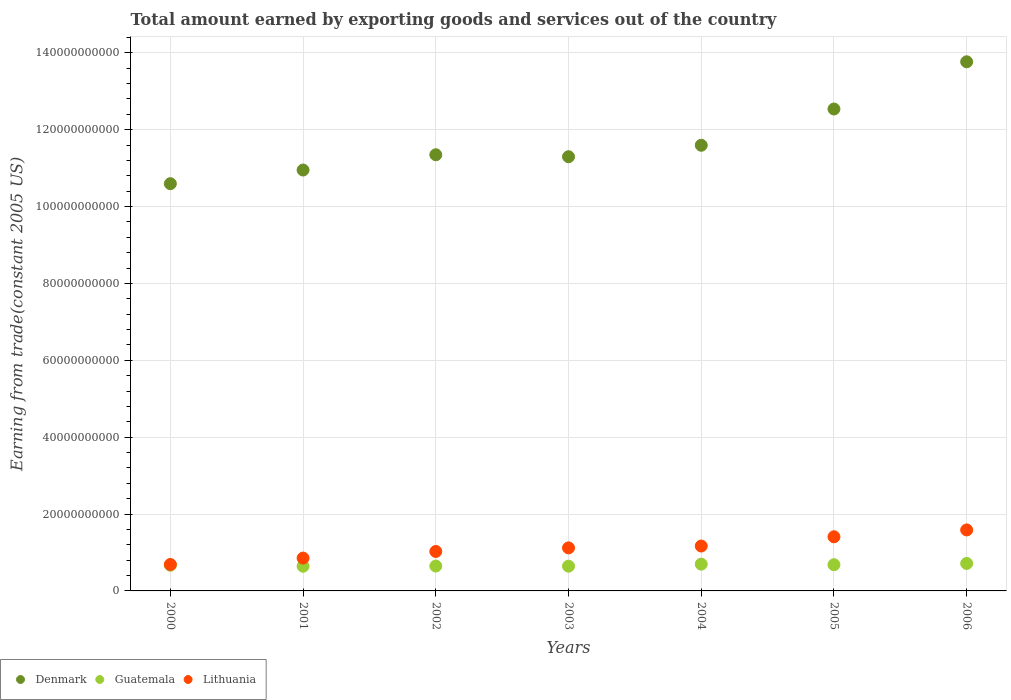How many different coloured dotlines are there?
Make the answer very short. 3. Is the number of dotlines equal to the number of legend labels?
Give a very brief answer. Yes. What is the total amount earned by exporting goods and services in Guatemala in 2000?
Provide a succinct answer. 6.69e+09. Across all years, what is the maximum total amount earned by exporting goods and services in Lithuania?
Give a very brief answer. 1.59e+1. Across all years, what is the minimum total amount earned by exporting goods and services in Denmark?
Offer a very short reply. 1.06e+11. In which year was the total amount earned by exporting goods and services in Denmark maximum?
Provide a short and direct response. 2006. In which year was the total amount earned by exporting goods and services in Lithuania minimum?
Make the answer very short. 2000. What is the total total amount earned by exporting goods and services in Lithuania in the graph?
Give a very brief answer. 7.85e+1. What is the difference between the total amount earned by exporting goods and services in Guatemala in 2002 and that in 2005?
Your answer should be very brief. -3.48e+08. What is the difference between the total amount earned by exporting goods and services in Lithuania in 2004 and the total amount earned by exporting goods and services in Guatemala in 2003?
Make the answer very short. 5.24e+09. What is the average total amount earned by exporting goods and services in Lithuania per year?
Your response must be concise. 1.12e+1. In the year 2006, what is the difference between the total amount earned by exporting goods and services in Lithuania and total amount earned by exporting goods and services in Guatemala?
Your answer should be very brief. 8.72e+09. In how many years, is the total amount earned by exporting goods and services in Denmark greater than 48000000000 US$?
Your response must be concise. 7. What is the ratio of the total amount earned by exporting goods and services in Lithuania in 2001 to that in 2002?
Make the answer very short. 0.83. Is the difference between the total amount earned by exporting goods and services in Lithuania in 2002 and 2003 greater than the difference between the total amount earned by exporting goods and services in Guatemala in 2002 and 2003?
Offer a very short reply. No. What is the difference between the highest and the second highest total amount earned by exporting goods and services in Guatemala?
Make the answer very short. 1.80e+08. What is the difference between the highest and the lowest total amount earned by exporting goods and services in Guatemala?
Give a very brief answer. 7.21e+08. Is it the case that in every year, the sum of the total amount earned by exporting goods and services in Denmark and total amount earned by exporting goods and services in Lithuania  is greater than the total amount earned by exporting goods and services in Guatemala?
Offer a very short reply. Yes. Does the total amount earned by exporting goods and services in Denmark monotonically increase over the years?
Keep it short and to the point. No. Is the total amount earned by exporting goods and services in Guatemala strictly less than the total amount earned by exporting goods and services in Lithuania over the years?
Offer a very short reply. Yes. How many years are there in the graph?
Make the answer very short. 7. What is the difference between two consecutive major ticks on the Y-axis?
Offer a very short reply. 2.00e+1. Are the values on the major ticks of Y-axis written in scientific E-notation?
Make the answer very short. No. What is the title of the graph?
Provide a succinct answer. Total amount earned by exporting goods and services out of the country. Does "Gabon" appear as one of the legend labels in the graph?
Your answer should be compact. No. What is the label or title of the Y-axis?
Provide a succinct answer. Earning from trade(constant 2005 US). What is the Earning from trade(constant 2005 US) in Denmark in 2000?
Your answer should be compact. 1.06e+11. What is the Earning from trade(constant 2005 US) in Guatemala in 2000?
Your answer should be compact. 6.69e+09. What is the Earning from trade(constant 2005 US) in Lithuania in 2000?
Keep it short and to the point. 6.88e+09. What is the Earning from trade(constant 2005 US) of Denmark in 2001?
Provide a succinct answer. 1.10e+11. What is the Earning from trade(constant 2005 US) of Guatemala in 2001?
Offer a very short reply. 6.42e+09. What is the Earning from trade(constant 2005 US) in Lithuania in 2001?
Make the answer very short. 8.54e+09. What is the Earning from trade(constant 2005 US) of Denmark in 2002?
Provide a succinct answer. 1.13e+11. What is the Earning from trade(constant 2005 US) in Guatemala in 2002?
Keep it short and to the point. 6.47e+09. What is the Earning from trade(constant 2005 US) of Lithuania in 2002?
Offer a terse response. 1.03e+1. What is the Earning from trade(constant 2005 US) in Denmark in 2003?
Provide a succinct answer. 1.13e+11. What is the Earning from trade(constant 2005 US) of Guatemala in 2003?
Offer a very short reply. 6.44e+09. What is the Earning from trade(constant 2005 US) in Lithuania in 2003?
Ensure brevity in your answer.  1.12e+1. What is the Earning from trade(constant 2005 US) in Denmark in 2004?
Provide a succinct answer. 1.16e+11. What is the Earning from trade(constant 2005 US) of Guatemala in 2004?
Make the answer very short. 6.96e+09. What is the Earning from trade(constant 2005 US) of Lithuania in 2004?
Provide a short and direct response. 1.17e+1. What is the Earning from trade(constant 2005 US) in Denmark in 2005?
Make the answer very short. 1.25e+11. What is the Earning from trade(constant 2005 US) in Guatemala in 2005?
Ensure brevity in your answer.  6.82e+09. What is the Earning from trade(constant 2005 US) in Lithuania in 2005?
Offer a very short reply. 1.41e+1. What is the Earning from trade(constant 2005 US) in Denmark in 2006?
Keep it short and to the point. 1.38e+11. What is the Earning from trade(constant 2005 US) of Guatemala in 2006?
Offer a terse response. 7.14e+09. What is the Earning from trade(constant 2005 US) of Lithuania in 2006?
Provide a short and direct response. 1.59e+1. Across all years, what is the maximum Earning from trade(constant 2005 US) of Denmark?
Offer a terse response. 1.38e+11. Across all years, what is the maximum Earning from trade(constant 2005 US) in Guatemala?
Keep it short and to the point. 7.14e+09. Across all years, what is the maximum Earning from trade(constant 2005 US) of Lithuania?
Give a very brief answer. 1.59e+1. Across all years, what is the minimum Earning from trade(constant 2005 US) of Denmark?
Your answer should be very brief. 1.06e+11. Across all years, what is the minimum Earning from trade(constant 2005 US) in Guatemala?
Provide a short and direct response. 6.42e+09. Across all years, what is the minimum Earning from trade(constant 2005 US) of Lithuania?
Provide a succinct answer. 6.88e+09. What is the total Earning from trade(constant 2005 US) in Denmark in the graph?
Keep it short and to the point. 8.21e+11. What is the total Earning from trade(constant 2005 US) in Guatemala in the graph?
Provide a short and direct response. 4.69e+1. What is the total Earning from trade(constant 2005 US) in Lithuania in the graph?
Provide a short and direct response. 7.85e+1. What is the difference between the Earning from trade(constant 2005 US) of Denmark in 2000 and that in 2001?
Your answer should be very brief. -3.55e+09. What is the difference between the Earning from trade(constant 2005 US) in Guatemala in 2000 and that in 2001?
Make the answer very short. 2.67e+08. What is the difference between the Earning from trade(constant 2005 US) in Lithuania in 2000 and that in 2001?
Offer a terse response. -1.66e+09. What is the difference between the Earning from trade(constant 2005 US) of Denmark in 2000 and that in 2002?
Make the answer very short. -7.53e+09. What is the difference between the Earning from trade(constant 2005 US) in Guatemala in 2000 and that in 2002?
Ensure brevity in your answer.  2.21e+08. What is the difference between the Earning from trade(constant 2005 US) of Lithuania in 2000 and that in 2002?
Your response must be concise. -3.38e+09. What is the difference between the Earning from trade(constant 2005 US) of Denmark in 2000 and that in 2003?
Provide a short and direct response. -7.02e+09. What is the difference between the Earning from trade(constant 2005 US) of Guatemala in 2000 and that in 2003?
Offer a terse response. 2.55e+08. What is the difference between the Earning from trade(constant 2005 US) in Lithuania in 2000 and that in 2003?
Offer a terse response. -4.31e+09. What is the difference between the Earning from trade(constant 2005 US) in Denmark in 2000 and that in 2004?
Make the answer very short. -1.00e+1. What is the difference between the Earning from trade(constant 2005 US) in Guatemala in 2000 and that in 2004?
Offer a very short reply. -2.74e+08. What is the difference between the Earning from trade(constant 2005 US) of Lithuania in 2000 and that in 2004?
Your response must be concise. -4.80e+09. What is the difference between the Earning from trade(constant 2005 US) in Denmark in 2000 and that in 2005?
Your answer should be very brief. -1.94e+1. What is the difference between the Earning from trade(constant 2005 US) in Guatemala in 2000 and that in 2005?
Your answer should be compact. -1.27e+08. What is the difference between the Earning from trade(constant 2005 US) in Lithuania in 2000 and that in 2005?
Your answer should be very brief. -7.20e+09. What is the difference between the Earning from trade(constant 2005 US) in Denmark in 2000 and that in 2006?
Give a very brief answer. -3.17e+1. What is the difference between the Earning from trade(constant 2005 US) in Guatemala in 2000 and that in 2006?
Ensure brevity in your answer.  -4.54e+08. What is the difference between the Earning from trade(constant 2005 US) of Lithuania in 2000 and that in 2006?
Give a very brief answer. -8.98e+09. What is the difference between the Earning from trade(constant 2005 US) in Denmark in 2001 and that in 2002?
Your answer should be very brief. -3.98e+09. What is the difference between the Earning from trade(constant 2005 US) in Guatemala in 2001 and that in 2002?
Offer a very short reply. -4.56e+07. What is the difference between the Earning from trade(constant 2005 US) of Lithuania in 2001 and that in 2002?
Keep it short and to the point. -1.72e+09. What is the difference between the Earning from trade(constant 2005 US) of Denmark in 2001 and that in 2003?
Your answer should be very brief. -3.47e+09. What is the difference between the Earning from trade(constant 2005 US) of Guatemala in 2001 and that in 2003?
Provide a succinct answer. -1.21e+07. What is the difference between the Earning from trade(constant 2005 US) in Lithuania in 2001 and that in 2003?
Your response must be concise. -2.66e+09. What is the difference between the Earning from trade(constant 2005 US) of Denmark in 2001 and that in 2004?
Ensure brevity in your answer.  -6.45e+09. What is the difference between the Earning from trade(constant 2005 US) in Guatemala in 2001 and that in 2004?
Your answer should be compact. -5.41e+08. What is the difference between the Earning from trade(constant 2005 US) in Lithuania in 2001 and that in 2004?
Ensure brevity in your answer.  -3.14e+09. What is the difference between the Earning from trade(constant 2005 US) in Denmark in 2001 and that in 2005?
Offer a terse response. -1.59e+1. What is the difference between the Earning from trade(constant 2005 US) of Guatemala in 2001 and that in 2005?
Your response must be concise. -3.94e+08. What is the difference between the Earning from trade(constant 2005 US) of Lithuania in 2001 and that in 2005?
Make the answer very short. -5.55e+09. What is the difference between the Earning from trade(constant 2005 US) in Denmark in 2001 and that in 2006?
Offer a terse response. -2.82e+1. What is the difference between the Earning from trade(constant 2005 US) in Guatemala in 2001 and that in 2006?
Give a very brief answer. -7.21e+08. What is the difference between the Earning from trade(constant 2005 US) in Lithuania in 2001 and that in 2006?
Your answer should be very brief. -7.32e+09. What is the difference between the Earning from trade(constant 2005 US) in Denmark in 2002 and that in 2003?
Ensure brevity in your answer.  5.10e+08. What is the difference between the Earning from trade(constant 2005 US) of Guatemala in 2002 and that in 2003?
Provide a succinct answer. 3.35e+07. What is the difference between the Earning from trade(constant 2005 US) of Lithuania in 2002 and that in 2003?
Provide a short and direct response. -9.31e+08. What is the difference between the Earning from trade(constant 2005 US) of Denmark in 2002 and that in 2004?
Offer a very short reply. -2.47e+09. What is the difference between the Earning from trade(constant 2005 US) in Guatemala in 2002 and that in 2004?
Give a very brief answer. -4.95e+08. What is the difference between the Earning from trade(constant 2005 US) of Lithuania in 2002 and that in 2004?
Make the answer very short. -1.41e+09. What is the difference between the Earning from trade(constant 2005 US) in Denmark in 2002 and that in 2005?
Your answer should be very brief. -1.19e+1. What is the difference between the Earning from trade(constant 2005 US) in Guatemala in 2002 and that in 2005?
Ensure brevity in your answer.  -3.48e+08. What is the difference between the Earning from trade(constant 2005 US) of Lithuania in 2002 and that in 2005?
Provide a short and direct response. -3.82e+09. What is the difference between the Earning from trade(constant 2005 US) of Denmark in 2002 and that in 2006?
Offer a very short reply. -2.42e+1. What is the difference between the Earning from trade(constant 2005 US) of Guatemala in 2002 and that in 2006?
Provide a short and direct response. -6.75e+08. What is the difference between the Earning from trade(constant 2005 US) in Lithuania in 2002 and that in 2006?
Provide a succinct answer. -5.60e+09. What is the difference between the Earning from trade(constant 2005 US) in Denmark in 2003 and that in 2004?
Make the answer very short. -2.98e+09. What is the difference between the Earning from trade(constant 2005 US) in Guatemala in 2003 and that in 2004?
Your answer should be compact. -5.29e+08. What is the difference between the Earning from trade(constant 2005 US) of Lithuania in 2003 and that in 2004?
Offer a very short reply. -4.83e+08. What is the difference between the Earning from trade(constant 2005 US) of Denmark in 2003 and that in 2005?
Your response must be concise. -1.24e+1. What is the difference between the Earning from trade(constant 2005 US) in Guatemala in 2003 and that in 2005?
Ensure brevity in your answer.  -3.82e+08. What is the difference between the Earning from trade(constant 2005 US) of Lithuania in 2003 and that in 2005?
Offer a terse response. -2.89e+09. What is the difference between the Earning from trade(constant 2005 US) of Denmark in 2003 and that in 2006?
Offer a terse response. -2.47e+1. What is the difference between the Earning from trade(constant 2005 US) of Guatemala in 2003 and that in 2006?
Offer a very short reply. -7.09e+08. What is the difference between the Earning from trade(constant 2005 US) of Lithuania in 2003 and that in 2006?
Offer a very short reply. -4.67e+09. What is the difference between the Earning from trade(constant 2005 US) in Denmark in 2004 and that in 2005?
Keep it short and to the point. -9.44e+09. What is the difference between the Earning from trade(constant 2005 US) in Guatemala in 2004 and that in 2005?
Make the answer very short. 1.47e+08. What is the difference between the Earning from trade(constant 2005 US) of Lithuania in 2004 and that in 2005?
Make the answer very short. -2.41e+09. What is the difference between the Earning from trade(constant 2005 US) of Denmark in 2004 and that in 2006?
Offer a terse response. -2.17e+1. What is the difference between the Earning from trade(constant 2005 US) in Guatemala in 2004 and that in 2006?
Offer a terse response. -1.80e+08. What is the difference between the Earning from trade(constant 2005 US) of Lithuania in 2004 and that in 2006?
Your answer should be very brief. -4.19e+09. What is the difference between the Earning from trade(constant 2005 US) in Denmark in 2005 and that in 2006?
Offer a very short reply. -1.23e+1. What is the difference between the Earning from trade(constant 2005 US) in Guatemala in 2005 and that in 2006?
Ensure brevity in your answer.  -3.27e+08. What is the difference between the Earning from trade(constant 2005 US) of Lithuania in 2005 and that in 2006?
Offer a very short reply. -1.78e+09. What is the difference between the Earning from trade(constant 2005 US) of Denmark in 2000 and the Earning from trade(constant 2005 US) of Guatemala in 2001?
Your response must be concise. 9.95e+1. What is the difference between the Earning from trade(constant 2005 US) of Denmark in 2000 and the Earning from trade(constant 2005 US) of Lithuania in 2001?
Your answer should be very brief. 9.74e+1. What is the difference between the Earning from trade(constant 2005 US) of Guatemala in 2000 and the Earning from trade(constant 2005 US) of Lithuania in 2001?
Your response must be concise. -1.85e+09. What is the difference between the Earning from trade(constant 2005 US) in Denmark in 2000 and the Earning from trade(constant 2005 US) in Guatemala in 2002?
Offer a terse response. 9.95e+1. What is the difference between the Earning from trade(constant 2005 US) in Denmark in 2000 and the Earning from trade(constant 2005 US) in Lithuania in 2002?
Keep it short and to the point. 9.57e+1. What is the difference between the Earning from trade(constant 2005 US) in Guatemala in 2000 and the Earning from trade(constant 2005 US) in Lithuania in 2002?
Offer a terse response. -3.58e+09. What is the difference between the Earning from trade(constant 2005 US) of Denmark in 2000 and the Earning from trade(constant 2005 US) of Guatemala in 2003?
Offer a terse response. 9.95e+1. What is the difference between the Earning from trade(constant 2005 US) of Denmark in 2000 and the Earning from trade(constant 2005 US) of Lithuania in 2003?
Offer a terse response. 9.48e+1. What is the difference between the Earning from trade(constant 2005 US) of Guatemala in 2000 and the Earning from trade(constant 2005 US) of Lithuania in 2003?
Give a very brief answer. -4.51e+09. What is the difference between the Earning from trade(constant 2005 US) in Denmark in 2000 and the Earning from trade(constant 2005 US) in Guatemala in 2004?
Your answer should be compact. 9.90e+1. What is the difference between the Earning from trade(constant 2005 US) of Denmark in 2000 and the Earning from trade(constant 2005 US) of Lithuania in 2004?
Give a very brief answer. 9.43e+1. What is the difference between the Earning from trade(constant 2005 US) of Guatemala in 2000 and the Earning from trade(constant 2005 US) of Lithuania in 2004?
Offer a very short reply. -4.99e+09. What is the difference between the Earning from trade(constant 2005 US) in Denmark in 2000 and the Earning from trade(constant 2005 US) in Guatemala in 2005?
Your response must be concise. 9.91e+1. What is the difference between the Earning from trade(constant 2005 US) in Denmark in 2000 and the Earning from trade(constant 2005 US) in Lithuania in 2005?
Ensure brevity in your answer.  9.19e+1. What is the difference between the Earning from trade(constant 2005 US) in Guatemala in 2000 and the Earning from trade(constant 2005 US) in Lithuania in 2005?
Offer a very short reply. -7.40e+09. What is the difference between the Earning from trade(constant 2005 US) of Denmark in 2000 and the Earning from trade(constant 2005 US) of Guatemala in 2006?
Make the answer very short. 9.88e+1. What is the difference between the Earning from trade(constant 2005 US) in Denmark in 2000 and the Earning from trade(constant 2005 US) in Lithuania in 2006?
Provide a succinct answer. 9.01e+1. What is the difference between the Earning from trade(constant 2005 US) in Guatemala in 2000 and the Earning from trade(constant 2005 US) in Lithuania in 2006?
Provide a succinct answer. -9.18e+09. What is the difference between the Earning from trade(constant 2005 US) in Denmark in 2001 and the Earning from trade(constant 2005 US) in Guatemala in 2002?
Make the answer very short. 1.03e+11. What is the difference between the Earning from trade(constant 2005 US) of Denmark in 2001 and the Earning from trade(constant 2005 US) of Lithuania in 2002?
Give a very brief answer. 9.92e+1. What is the difference between the Earning from trade(constant 2005 US) of Guatemala in 2001 and the Earning from trade(constant 2005 US) of Lithuania in 2002?
Your answer should be compact. -3.84e+09. What is the difference between the Earning from trade(constant 2005 US) of Denmark in 2001 and the Earning from trade(constant 2005 US) of Guatemala in 2003?
Your response must be concise. 1.03e+11. What is the difference between the Earning from trade(constant 2005 US) in Denmark in 2001 and the Earning from trade(constant 2005 US) in Lithuania in 2003?
Keep it short and to the point. 9.83e+1. What is the difference between the Earning from trade(constant 2005 US) of Guatemala in 2001 and the Earning from trade(constant 2005 US) of Lithuania in 2003?
Your answer should be very brief. -4.77e+09. What is the difference between the Earning from trade(constant 2005 US) of Denmark in 2001 and the Earning from trade(constant 2005 US) of Guatemala in 2004?
Make the answer very short. 1.03e+11. What is the difference between the Earning from trade(constant 2005 US) in Denmark in 2001 and the Earning from trade(constant 2005 US) in Lithuania in 2004?
Your answer should be compact. 9.78e+1. What is the difference between the Earning from trade(constant 2005 US) of Guatemala in 2001 and the Earning from trade(constant 2005 US) of Lithuania in 2004?
Ensure brevity in your answer.  -5.26e+09. What is the difference between the Earning from trade(constant 2005 US) in Denmark in 2001 and the Earning from trade(constant 2005 US) in Guatemala in 2005?
Your answer should be very brief. 1.03e+11. What is the difference between the Earning from trade(constant 2005 US) in Denmark in 2001 and the Earning from trade(constant 2005 US) in Lithuania in 2005?
Your answer should be very brief. 9.54e+1. What is the difference between the Earning from trade(constant 2005 US) in Guatemala in 2001 and the Earning from trade(constant 2005 US) in Lithuania in 2005?
Provide a short and direct response. -7.66e+09. What is the difference between the Earning from trade(constant 2005 US) of Denmark in 2001 and the Earning from trade(constant 2005 US) of Guatemala in 2006?
Your answer should be very brief. 1.02e+11. What is the difference between the Earning from trade(constant 2005 US) in Denmark in 2001 and the Earning from trade(constant 2005 US) in Lithuania in 2006?
Your answer should be compact. 9.36e+1. What is the difference between the Earning from trade(constant 2005 US) in Guatemala in 2001 and the Earning from trade(constant 2005 US) in Lithuania in 2006?
Give a very brief answer. -9.44e+09. What is the difference between the Earning from trade(constant 2005 US) in Denmark in 2002 and the Earning from trade(constant 2005 US) in Guatemala in 2003?
Offer a very short reply. 1.07e+11. What is the difference between the Earning from trade(constant 2005 US) in Denmark in 2002 and the Earning from trade(constant 2005 US) in Lithuania in 2003?
Offer a very short reply. 1.02e+11. What is the difference between the Earning from trade(constant 2005 US) in Guatemala in 2002 and the Earning from trade(constant 2005 US) in Lithuania in 2003?
Your answer should be compact. -4.73e+09. What is the difference between the Earning from trade(constant 2005 US) of Denmark in 2002 and the Earning from trade(constant 2005 US) of Guatemala in 2004?
Keep it short and to the point. 1.07e+11. What is the difference between the Earning from trade(constant 2005 US) in Denmark in 2002 and the Earning from trade(constant 2005 US) in Lithuania in 2004?
Give a very brief answer. 1.02e+11. What is the difference between the Earning from trade(constant 2005 US) of Guatemala in 2002 and the Earning from trade(constant 2005 US) of Lithuania in 2004?
Provide a succinct answer. -5.21e+09. What is the difference between the Earning from trade(constant 2005 US) in Denmark in 2002 and the Earning from trade(constant 2005 US) in Guatemala in 2005?
Provide a short and direct response. 1.07e+11. What is the difference between the Earning from trade(constant 2005 US) of Denmark in 2002 and the Earning from trade(constant 2005 US) of Lithuania in 2005?
Your answer should be compact. 9.94e+1. What is the difference between the Earning from trade(constant 2005 US) of Guatemala in 2002 and the Earning from trade(constant 2005 US) of Lithuania in 2005?
Your response must be concise. -7.62e+09. What is the difference between the Earning from trade(constant 2005 US) in Denmark in 2002 and the Earning from trade(constant 2005 US) in Guatemala in 2006?
Provide a succinct answer. 1.06e+11. What is the difference between the Earning from trade(constant 2005 US) in Denmark in 2002 and the Earning from trade(constant 2005 US) in Lithuania in 2006?
Ensure brevity in your answer.  9.76e+1. What is the difference between the Earning from trade(constant 2005 US) in Guatemala in 2002 and the Earning from trade(constant 2005 US) in Lithuania in 2006?
Offer a terse response. -9.40e+09. What is the difference between the Earning from trade(constant 2005 US) in Denmark in 2003 and the Earning from trade(constant 2005 US) in Guatemala in 2004?
Make the answer very short. 1.06e+11. What is the difference between the Earning from trade(constant 2005 US) of Denmark in 2003 and the Earning from trade(constant 2005 US) of Lithuania in 2004?
Provide a short and direct response. 1.01e+11. What is the difference between the Earning from trade(constant 2005 US) of Guatemala in 2003 and the Earning from trade(constant 2005 US) of Lithuania in 2004?
Ensure brevity in your answer.  -5.24e+09. What is the difference between the Earning from trade(constant 2005 US) in Denmark in 2003 and the Earning from trade(constant 2005 US) in Guatemala in 2005?
Your answer should be very brief. 1.06e+11. What is the difference between the Earning from trade(constant 2005 US) of Denmark in 2003 and the Earning from trade(constant 2005 US) of Lithuania in 2005?
Give a very brief answer. 9.89e+1. What is the difference between the Earning from trade(constant 2005 US) in Guatemala in 2003 and the Earning from trade(constant 2005 US) in Lithuania in 2005?
Make the answer very short. -7.65e+09. What is the difference between the Earning from trade(constant 2005 US) in Denmark in 2003 and the Earning from trade(constant 2005 US) in Guatemala in 2006?
Keep it short and to the point. 1.06e+11. What is the difference between the Earning from trade(constant 2005 US) in Denmark in 2003 and the Earning from trade(constant 2005 US) in Lithuania in 2006?
Ensure brevity in your answer.  9.71e+1. What is the difference between the Earning from trade(constant 2005 US) in Guatemala in 2003 and the Earning from trade(constant 2005 US) in Lithuania in 2006?
Ensure brevity in your answer.  -9.43e+09. What is the difference between the Earning from trade(constant 2005 US) of Denmark in 2004 and the Earning from trade(constant 2005 US) of Guatemala in 2005?
Provide a succinct answer. 1.09e+11. What is the difference between the Earning from trade(constant 2005 US) of Denmark in 2004 and the Earning from trade(constant 2005 US) of Lithuania in 2005?
Give a very brief answer. 1.02e+11. What is the difference between the Earning from trade(constant 2005 US) in Guatemala in 2004 and the Earning from trade(constant 2005 US) in Lithuania in 2005?
Your answer should be very brief. -7.12e+09. What is the difference between the Earning from trade(constant 2005 US) in Denmark in 2004 and the Earning from trade(constant 2005 US) in Guatemala in 2006?
Offer a terse response. 1.09e+11. What is the difference between the Earning from trade(constant 2005 US) of Denmark in 2004 and the Earning from trade(constant 2005 US) of Lithuania in 2006?
Give a very brief answer. 1.00e+11. What is the difference between the Earning from trade(constant 2005 US) in Guatemala in 2004 and the Earning from trade(constant 2005 US) in Lithuania in 2006?
Your answer should be compact. -8.90e+09. What is the difference between the Earning from trade(constant 2005 US) of Denmark in 2005 and the Earning from trade(constant 2005 US) of Guatemala in 2006?
Keep it short and to the point. 1.18e+11. What is the difference between the Earning from trade(constant 2005 US) of Denmark in 2005 and the Earning from trade(constant 2005 US) of Lithuania in 2006?
Offer a terse response. 1.10e+11. What is the difference between the Earning from trade(constant 2005 US) of Guatemala in 2005 and the Earning from trade(constant 2005 US) of Lithuania in 2006?
Keep it short and to the point. -9.05e+09. What is the average Earning from trade(constant 2005 US) in Denmark per year?
Give a very brief answer. 1.17e+11. What is the average Earning from trade(constant 2005 US) of Guatemala per year?
Make the answer very short. 6.71e+09. What is the average Earning from trade(constant 2005 US) in Lithuania per year?
Provide a succinct answer. 1.12e+1. In the year 2000, what is the difference between the Earning from trade(constant 2005 US) of Denmark and Earning from trade(constant 2005 US) of Guatemala?
Your answer should be compact. 9.93e+1. In the year 2000, what is the difference between the Earning from trade(constant 2005 US) of Denmark and Earning from trade(constant 2005 US) of Lithuania?
Your response must be concise. 9.91e+1. In the year 2000, what is the difference between the Earning from trade(constant 2005 US) of Guatemala and Earning from trade(constant 2005 US) of Lithuania?
Provide a succinct answer. -1.94e+08. In the year 2001, what is the difference between the Earning from trade(constant 2005 US) of Denmark and Earning from trade(constant 2005 US) of Guatemala?
Ensure brevity in your answer.  1.03e+11. In the year 2001, what is the difference between the Earning from trade(constant 2005 US) in Denmark and Earning from trade(constant 2005 US) in Lithuania?
Your answer should be compact. 1.01e+11. In the year 2001, what is the difference between the Earning from trade(constant 2005 US) in Guatemala and Earning from trade(constant 2005 US) in Lithuania?
Offer a very short reply. -2.12e+09. In the year 2002, what is the difference between the Earning from trade(constant 2005 US) in Denmark and Earning from trade(constant 2005 US) in Guatemala?
Keep it short and to the point. 1.07e+11. In the year 2002, what is the difference between the Earning from trade(constant 2005 US) of Denmark and Earning from trade(constant 2005 US) of Lithuania?
Provide a short and direct response. 1.03e+11. In the year 2002, what is the difference between the Earning from trade(constant 2005 US) of Guatemala and Earning from trade(constant 2005 US) of Lithuania?
Make the answer very short. -3.80e+09. In the year 2003, what is the difference between the Earning from trade(constant 2005 US) in Denmark and Earning from trade(constant 2005 US) in Guatemala?
Offer a terse response. 1.07e+11. In the year 2003, what is the difference between the Earning from trade(constant 2005 US) in Denmark and Earning from trade(constant 2005 US) in Lithuania?
Your answer should be very brief. 1.02e+11. In the year 2003, what is the difference between the Earning from trade(constant 2005 US) in Guatemala and Earning from trade(constant 2005 US) in Lithuania?
Offer a very short reply. -4.76e+09. In the year 2004, what is the difference between the Earning from trade(constant 2005 US) in Denmark and Earning from trade(constant 2005 US) in Guatemala?
Keep it short and to the point. 1.09e+11. In the year 2004, what is the difference between the Earning from trade(constant 2005 US) in Denmark and Earning from trade(constant 2005 US) in Lithuania?
Your answer should be compact. 1.04e+11. In the year 2004, what is the difference between the Earning from trade(constant 2005 US) of Guatemala and Earning from trade(constant 2005 US) of Lithuania?
Ensure brevity in your answer.  -4.72e+09. In the year 2005, what is the difference between the Earning from trade(constant 2005 US) in Denmark and Earning from trade(constant 2005 US) in Guatemala?
Offer a terse response. 1.19e+11. In the year 2005, what is the difference between the Earning from trade(constant 2005 US) of Denmark and Earning from trade(constant 2005 US) of Lithuania?
Provide a succinct answer. 1.11e+11. In the year 2005, what is the difference between the Earning from trade(constant 2005 US) of Guatemala and Earning from trade(constant 2005 US) of Lithuania?
Ensure brevity in your answer.  -7.27e+09. In the year 2006, what is the difference between the Earning from trade(constant 2005 US) in Denmark and Earning from trade(constant 2005 US) in Guatemala?
Ensure brevity in your answer.  1.31e+11. In the year 2006, what is the difference between the Earning from trade(constant 2005 US) in Denmark and Earning from trade(constant 2005 US) in Lithuania?
Provide a short and direct response. 1.22e+11. In the year 2006, what is the difference between the Earning from trade(constant 2005 US) in Guatemala and Earning from trade(constant 2005 US) in Lithuania?
Make the answer very short. -8.72e+09. What is the ratio of the Earning from trade(constant 2005 US) in Denmark in 2000 to that in 2001?
Give a very brief answer. 0.97. What is the ratio of the Earning from trade(constant 2005 US) of Guatemala in 2000 to that in 2001?
Your answer should be very brief. 1.04. What is the ratio of the Earning from trade(constant 2005 US) of Lithuania in 2000 to that in 2001?
Your answer should be very brief. 0.81. What is the ratio of the Earning from trade(constant 2005 US) in Denmark in 2000 to that in 2002?
Give a very brief answer. 0.93. What is the ratio of the Earning from trade(constant 2005 US) of Guatemala in 2000 to that in 2002?
Your response must be concise. 1.03. What is the ratio of the Earning from trade(constant 2005 US) in Lithuania in 2000 to that in 2002?
Provide a succinct answer. 0.67. What is the ratio of the Earning from trade(constant 2005 US) in Denmark in 2000 to that in 2003?
Provide a succinct answer. 0.94. What is the ratio of the Earning from trade(constant 2005 US) in Guatemala in 2000 to that in 2003?
Provide a succinct answer. 1.04. What is the ratio of the Earning from trade(constant 2005 US) of Lithuania in 2000 to that in 2003?
Your answer should be compact. 0.61. What is the ratio of the Earning from trade(constant 2005 US) of Denmark in 2000 to that in 2004?
Your answer should be very brief. 0.91. What is the ratio of the Earning from trade(constant 2005 US) in Guatemala in 2000 to that in 2004?
Provide a succinct answer. 0.96. What is the ratio of the Earning from trade(constant 2005 US) of Lithuania in 2000 to that in 2004?
Provide a short and direct response. 0.59. What is the ratio of the Earning from trade(constant 2005 US) in Denmark in 2000 to that in 2005?
Give a very brief answer. 0.84. What is the ratio of the Earning from trade(constant 2005 US) of Guatemala in 2000 to that in 2005?
Offer a very short reply. 0.98. What is the ratio of the Earning from trade(constant 2005 US) of Lithuania in 2000 to that in 2005?
Keep it short and to the point. 0.49. What is the ratio of the Earning from trade(constant 2005 US) of Denmark in 2000 to that in 2006?
Keep it short and to the point. 0.77. What is the ratio of the Earning from trade(constant 2005 US) in Guatemala in 2000 to that in 2006?
Keep it short and to the point. 0.94. What is the ratio of the Earning from trade(constant 2005 US) in Lithuania in 2000 to that in 2006?
Your answer should be compact. 0.43. What is the ratio of the Earning from trade(constant 2005 US) in Guatemala in 2001 to that in 2002?
Offer a terse response. 0.99. What is the ratio of the Earning from trade(constant 2005 US) in Lithuania in 2001 to that in 2002?
Ensure brevity in your answer.  0.83. What is the ratio of the Earning from trade(constant 2005 US) of Denmark in 2001 to that in 2003?
Make the answer very short. 0.97. What is the ratio of the Earning from trade(constant 2005 US) in Guatemala in 2001 to that in 2003?
Your response must be concise. 1. What is the ratio of the Earning from trade(constant 2005 US) in Lithuania in 2001 to that in 2003?
Make the answer very short. 0.76. What is the ratio of the Earning from trade(constant 2005 US) in Denmark in 2001 to that in 2004?
Provide a succinct answer. 0.94. What is the ratio of the Earning from trade(constant 2005 US) of Guatemala in 2001 to that in 2004?
Provide a short and direct response. 0.92. What is the ratio of the Earning from trade(constant 2005 US) of Lithuania in 2001 to that in 2004?
Provide a short and direct response. 0.73. What is the ratio of the Earning from trade(constant 2005 US) in Denmark in 2001 to that in 2005?
Offer a terse response. 0.87. What is the ratio of the Earning from trade(constant 2005 US) of Guatemala in 2001 to that in 2005?
Provide a succinct answer. 0.94. What is the ratio of the Earning from trade(constant 2005 US) in Lithuania in 2001 to that in 2005?
Offer a terse response. 0.61. What is the ratio of the Earning from trade(constant 2005 US) in Denmark in 2001 to that in 2006?
Your response must be concise. 0.8. What is the ratio of the Earning from trade(constant 2005 US) in Guatemala in 2001 to that in 2006?
Make the answer very short. 0.9. What is the ratio of the Earning from trade(constant 2005 US) of Lithuania in 2001 to that in 2006?
Your response must be concise. 0.54. What is the ratio of the Earning from trade(constant 2005 US) in Denmark in 2002 to that in 2003?
Ensure brevity in your answer.  1. What is the ratio of the Earning from trade(constant 2005 US) of Guatemala in 2002 to that in 2003?
Your answer should be compact. 1.01. What is the ratio of the Earning from trade(constant 2005 US) of Lithuania in 2002 to that in 2003?
Offer a terse response. 0.92. What is the ratio of the Earning from trade(constant 2005 US) in Denmark in 2002 to that in 2004?
Your response must be concise. 0.98. What is the ratio of the Earning from trade(constant 2005 US) in Guatemala in 2002 to that in 2004?
Provide a succinct answer. 0.93. What is the ratio of the Earning from trade(constant 2005 US) in Lithuania in 2002 to that in 2004?
Provide a succinct answer. 0.88. What is the ratio of the Earning from trade(constant 2005 US) of Denmark in 2002 to that in 2005?
Provide a succinct answer. 0.91. What is the ratio of the Earning from trade(constant 2005 US) in Guatemala in 2002 to that in 2005?
Provide a short and direct response. 0.95. What is the ratio of the Earning from trade(constant 2005 US) of Lithuania in 2002 to that in 2005?
Your answer should be compact. 0.73. What is the ratio of the Earning from trade(constant 2005 US) of Denmark in 2002 to that in 2006?
Offer a terse response. 0.82. What is the ratio of the Earning from trade(constant 2005 US) of Guatemala in 2002 to that in 2006?
Provide a short and direct response. 0.91. What is the ratio of the Earning from trade(constant 2005 US) in Lithuania in 2002 to that in 2006?
Provide a succinct answer. 0.65. What is the ratio of the Earning from trade(constant 2005 US) in Denmark in 2003 to that in 2004?
Offer a very short reply. 0.97. What is the ratio of the Earning from trade(constant 2005 US) of Guatemala in 2003 to that in 2004?
Provide a succinct answer. 0.92. What is the ratio of the Earning from trade(constant 2005 US) of Lithuania in 2003 to that in 2004?
Offer a very short reply. 0.96. What is the ratio of the Earning from trade(constant 2005 US) in Denmark in 2003 to that in 2005?
Make the answer very short. 0.9. What is the ratio of the Earning from trade(constant 2005 US) in Guatemala in 2003 to that in 2005?
Provide a succinct answer. 0.94. What is the ratio of the Earning from trade(constant 2005 US) of Lithuania in 2003 to that in 2005?
Provide a succinct answer. 0.79. What is the ratio of the Earning from trade(constant 2005 US) of Denmark in 2003 to that in 2006?
Your answer should be compact. 0.82. What is the ratio of the Earning from trade(constant 2005 US) in Guatemala in 2003 to that in 2006?
Offer a terse response. 0.9. What is the ratio of the Earning from trade(constant 2005 US) in Lithuania in 2003 to that in 2006?
Ensure brevity in your answer.  0.71. What is the ratio of the Earning from trade(constant 2005 US) of Denmark in 2004 to that in 2005?
Give a very brief answer. 0.92. What is the ratio of the Earning from trade(constant 2005 US) in Guatemala in 2004 to that in 2005?
Your answer should be compact. 1.02. What is the ratio of the Earning from trade(constant 2005 US) in Lithuania in 2004 to that in 2005?
Give a very brief answer. 0.83. What is the ratio of the Earning from trade(constant 2005 US) of Denmark in 2004 to that in 2006?
Ensure brevity in your answer.  0.84. What is the ratio of the Earning from trade(constant 2005 US) in Guatemala in 2004 to that in 2006?
Provide a short and direct response. 0.97. What is the ratio of the Earning from trade(constant 2005 US) of Lithuania in 2004 to that in 2006?
Ensure brevity in your answer.  0.74. What is the ratio of the Earning from trade(constant 2005 US) in Denmark in 2005 to that in 2006?
Make the answer very short. 0.91. What is the ratio of the Earning from trade(constant 2005 US) of Guatemala in 2005 to that in 2006?
Offer a terse response. 0.95. What is the ratio of the Earning from trade(constant 2005 US) in Lithuania in 2005 to that in 2006?
Provide a short and direct response. 0.89. What is the difference between the highest and the second highest Earning from trade(constant 2005 US) of Denmark?
Provide a short and direct response. 1.23e+1. What is the difference between the highest and the second highest Earning from trade(constant 2005 US) in Guatemala?
Give a very brief answer. 1.80e+08. What is the difference between the highest and the second highest Earning from trade(constant 2005 US) in Lithuania?
Your answer should be very brief. 1.78e+09. What is the difference between the highest and the lowest Earning from trade(constant 2005 US) of Denmark?
Offer a terse response. 3.17e+1. What is the difference between the highest and the lowest Earning from trade(constant 2005 US) in Guatemala?
Your answer should be compact. 7.21e+08. What is the difference between the highest and the lowest Earning from trade(constant 2005 US) of Lithuania?
Offer a terse response. 8.98e+09. 